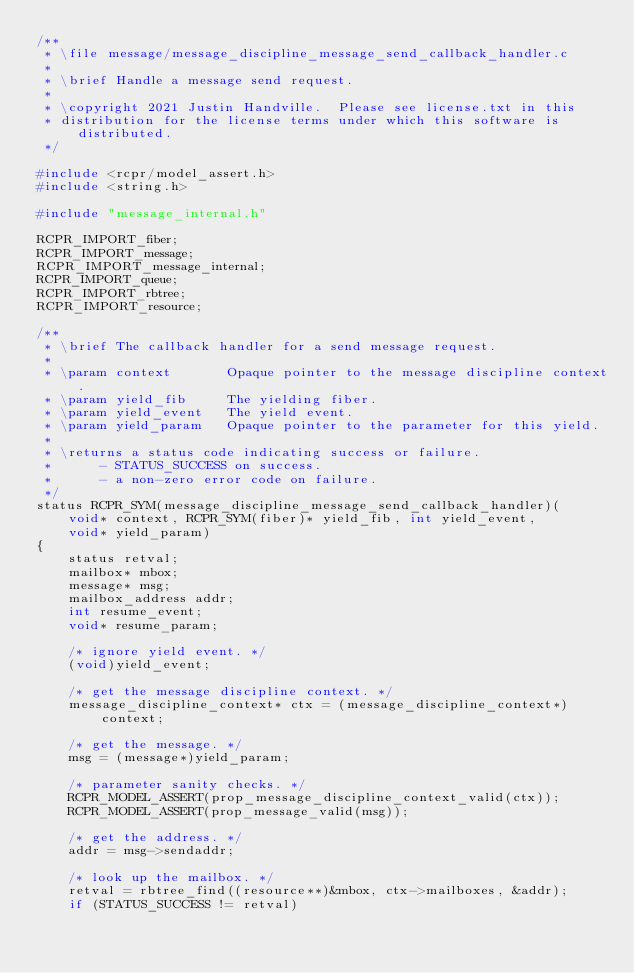Convert code to text. <code><loc_0><loc_0><loc_500><loc_500><_C_>/**
 * \file message/message_discipline_message_send_callback_handler.c
 *
 * \brief Handle a message send request.
 *
 * \copyright 2021 Justin Handville.  Please see license.txt in this
 * distribution for the license terms under which this software is distributed.
 */

#include <rcpr/model_assert.h>
#include <string.h>

#include "message_internal.h"

RCPR_IMPORT_fiber;
RCPR_IMPORT_message;
RCPR_IMPORT_message_internal;
RCPR_IMPORT_queue;
RCPR_IMPORT_rbtree;
RCPR_IMPORT_resource;

/**
 * \brief The callback handler for a send message request.
 *
 * \param context       Opaque pointer to the message discipline context.
 * \param yield_fib     The yielding fiber.
 * \param yield_event   The yield event.
 * \param yield_param   Opaque pointer to the parameter for this yield.
 *
 * \returns a status code indicating success or failure.
 *      - STATUS_SUCCESS on success.
 *      - a non-zero error code on failure.
 */
status RCPR_SYM(message_discipline_message_send_callback_handler)(
    void* context, RCPR_SYM(fiber)* yield_fib, int yield_event,
    void* yield_param)
{
    status retval;
    mailbox* mbox;
    message* msg;
    mailbox_address addr;
    int resume_event;
    void* resume_param;

    /* ignore yield event. */
    (void)yield_event;

    /* get the message discipline context. */
    message_discipline_context* ctx = (message_discipline_context*)context;

    /* get the message. */
    msg = (message*)yield_param;

    /* parameter sanity checks. */
    RCPR_MODEL_ASSERT(prop_message_discipline_context_valid(ctx));
    RCPR_MODEL_ASSERT(prop_message_valid(msg));

    /* get the address. */
    addr = msg->sendaddr;

    /* look up the mailbox. */
    retval = rbtree_find((resource**)&mbox, ctx->mailboxes, &addr);
    if (STATUS_SUCCESS != retval)</code> 